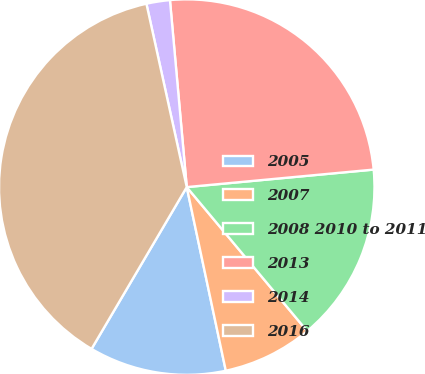Convert chart to OTSL. <chart><loc_0><loc_0><loc_500><loc_500><pie_chart><fcel>2005<fcel>2007<fcel>2008 2010 to 2011<fcel>2013<fcel>2014<fcel>2016<nl><fcel>11.8%<fcel>7.75%<fcel>15.4%<fcel>24.94%<fcel>2.02%<fcel>38.09%<nl></chart> 